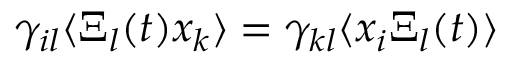<formula> <loc_0><loc_0><loc_500><loc_500>\gamma _ { i l } \langle \Xi _ { l } ( t ) x _ { k } \rangle = \gamma _ { k l } \langle x _ { i } \Xi _ { l } ( t ) \rangle</formula> 